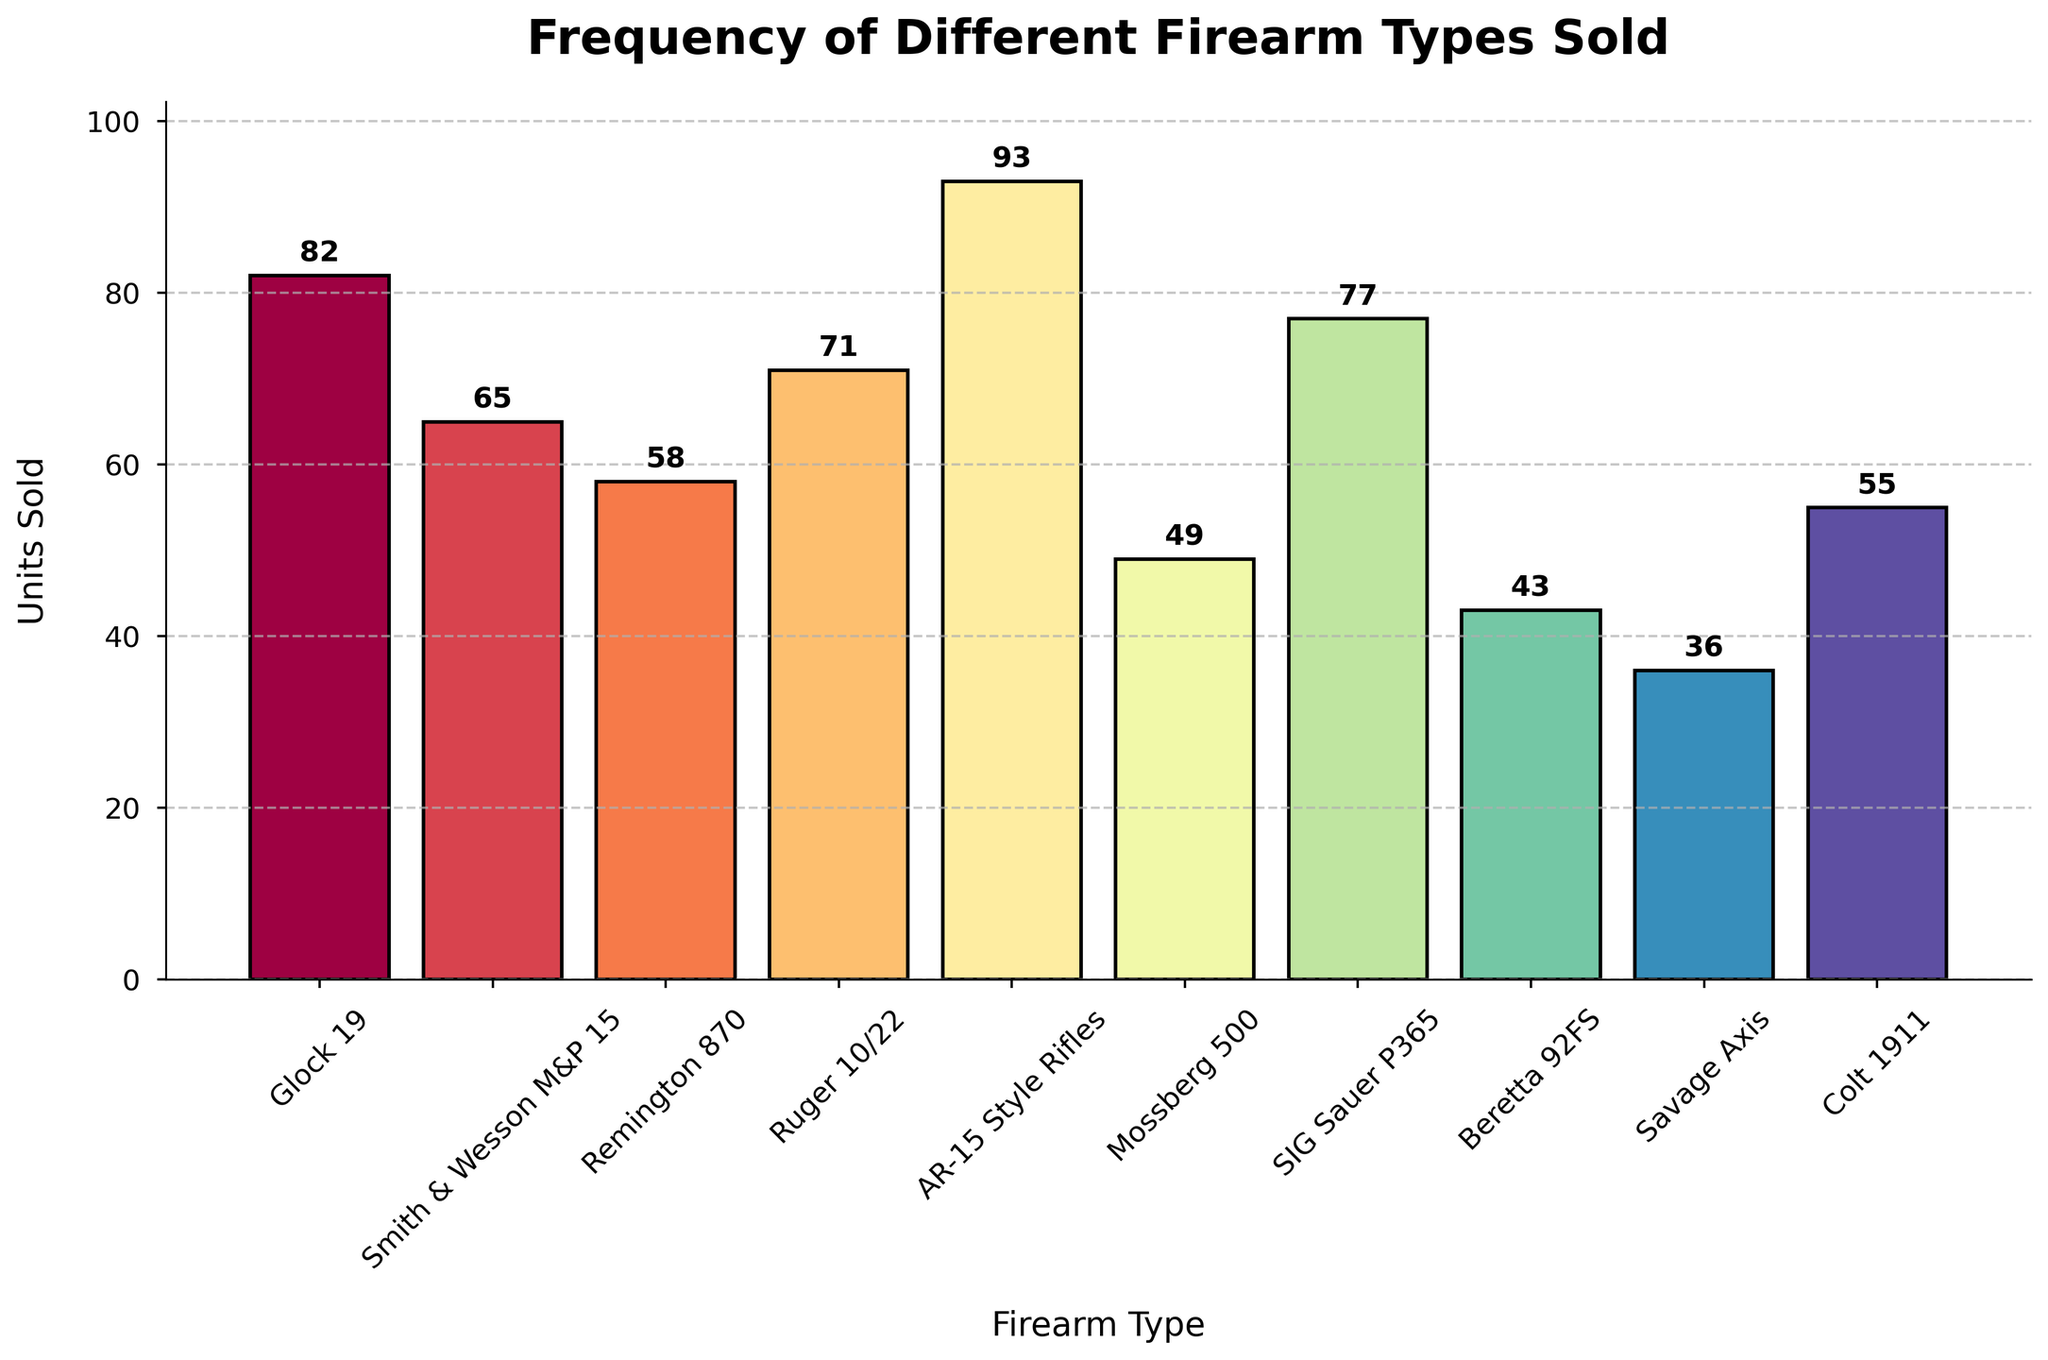what's the title of the figure? The title of the figure is displayed at the top and indicates the main subject of the data visualization.
Answer: Frequency of Different Firearm Types Sold what's the label on the x-axis? The label on the x-axis is found below the bar chart, describing what the horizontal axis represents.
Answer: Firearm Type how many units of the Glock 19 were sold? Look at the height of the bar corresponding to Glock 19 and read the value displayed above it.
Answer: 82 which firearm type has the highest units sold? Identify the tallest bar in the histogram and check the corresponding firearm type label on the x-axis.
Answer: AR-15 Style Rifles How many more units of the AR-15 Style Rifles were sold compared to the Beretta 92FS? Subtract the number of Beretta 92FS units sold from the number of AR-15 Style Rifles units sold. That is 93 - 43.
Answer: 50 what's the average number of units sold for the Ruger 10/22, SIG Sauer P365, and Colt 1911? Add the units sold for these three firearms and divide by 3. (71 + 77 + 55) / 3 = 67.67.
Answer: 67.67 how many different firearm types are there in the figure? Count the number of unique labels on the x-axis.
Answer: 10 which firearm type has sold the least units? Identify the shortest bar in the histogram and check the corresponding firearm type label on the x-axis.
Answer: Savage Axis compare the total units sold of rifles (e.g., AR-15 Style Rifles, Savage Axis, Smith & Wesson M&P 15) with shotguns (e.g., Mossberg 500, Remington 870). Which category sold more units? Add the units sold for each category and compare the totals. Rifles: 93 + 36 + 65 = 194; Shotguns: 49 + 58 = 107.
Answer: Rifles describe the color scheme used in the histogram. The histogram uses a range of colors from a gradient, with each bar having a distinct color and an edge that is outlined in black.
Answer: A gradient of colors with black edges 